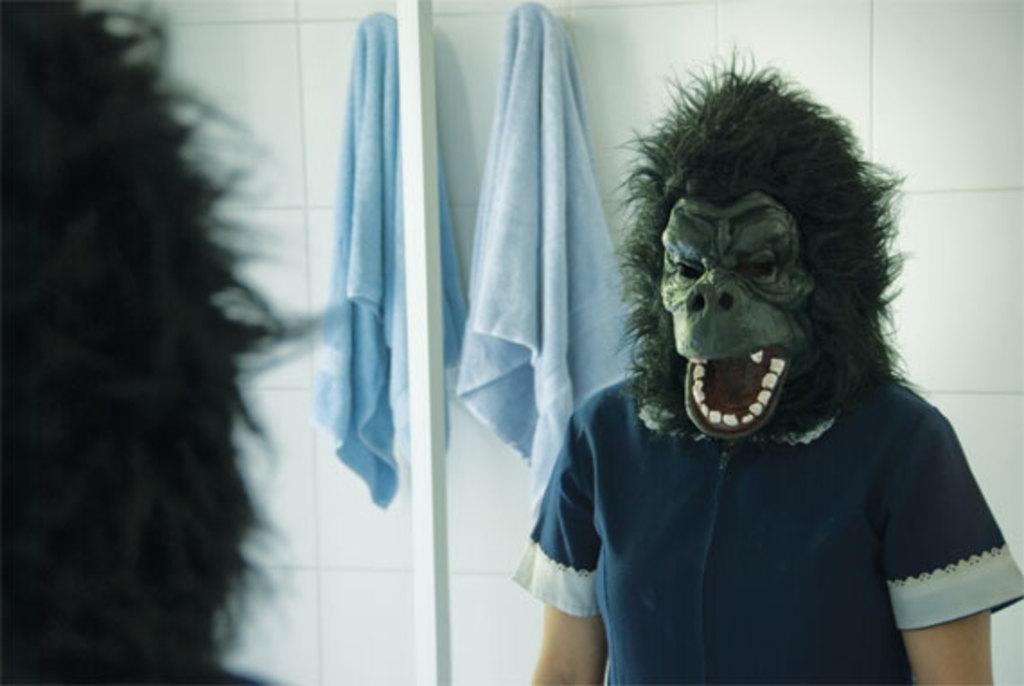Describe this image in one or two sentences. In the picture we can see a reflection in the mirror of a person with chimpanzee mask and behind the person we can see a towel on the wall. 